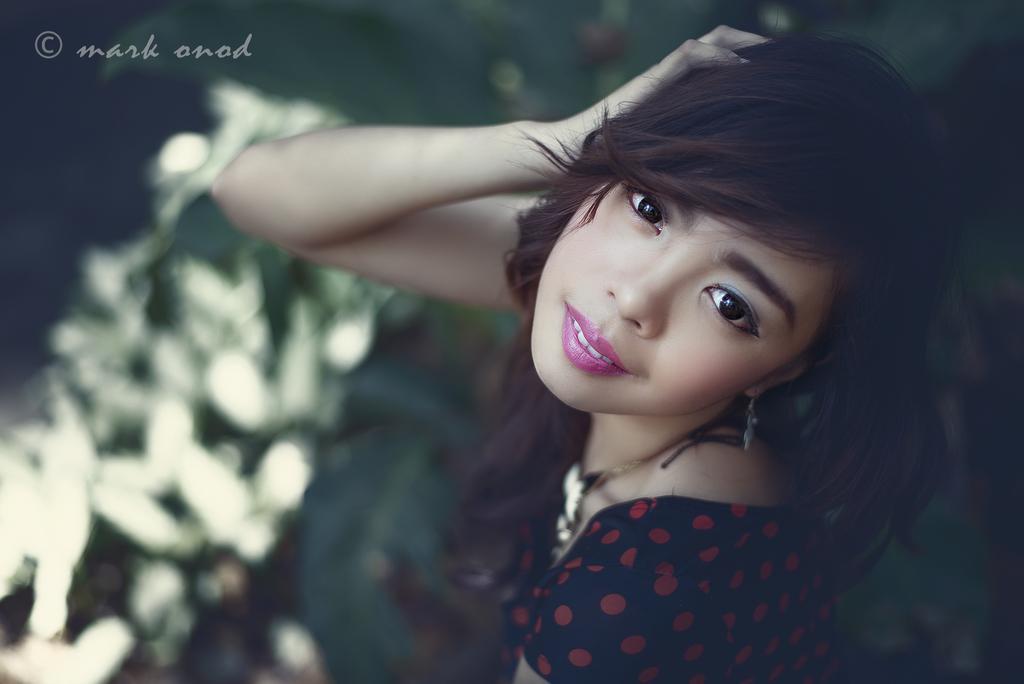How would you summarize this image in a sentence or two? In this image I can see a person and the person is wearing black and red color dress, and I can see blurred background. 